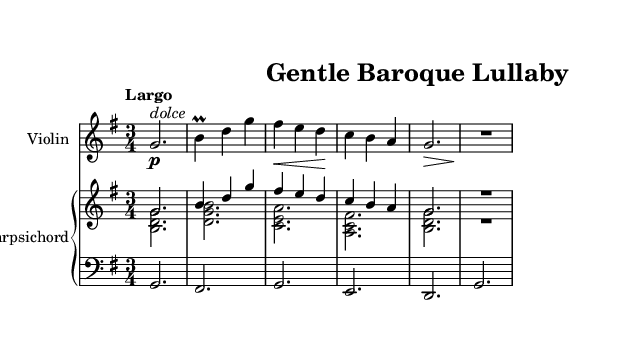What is the key signature of this music? The key signature is G major, which has one sharp (F#). This is indicated by the presence of the F# note in the melody, and it's the key signature associated with the treble staff.
Answer: G major What is the time signature of this music? The time signature is 3/4, which indicates three beats in each measure and a quarter note receives one beat. This is clear from the notation at the beginning showing a '3' over a '4'.
Answer: 3/4 What is the tempo marking of this piece? The tempo marking is Largo, which is a term that indicates the piece should be played slowly and broadly. This is specified at the beginning of the score.
Answer: Largo How many measures are in the violin part? There are 5 measures in the violin part, as evidenced by counting the vertical lines (bar lines) in the score separating each measure.
Answer: 5 measures What is the dynamics marking for the violin in the first measure? The dynamics marking is "p" for piano, which means to play softly. This is indicated right above the first note in the violin part.
Answer: piano What does the term "dolce" indicate for the violin? The term "dolce" indicates that the passage should be played sweetly or gently. It is marked above the note in the first measure of the violin part, directing the performer to play in a soft and delicate manner.
Answer: sweetly What instrument is the primary accompaniment for the violin? The primary accompaniment is the harpsichord. It is indicated in the score as well, where the harpsichord plays chords that support the violin melody throughout the piece.
Answer: harpsichord 